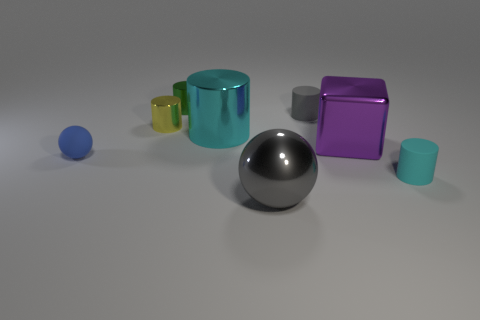There is a cylinder that is the same color as the large sphere; what material is it?
Offer a very short reply. Rubber. The matte cylinder that is the same color as the shiny sphere is what size?
Offer a very short reply. Small. Is the number of green metallic objects that are in front of the big gray shiny thing less than the number of purple blocks to the left of the yellow metallic object?
Make the answer very short. No. Is there any other thing that is the same material as the big cube?
Keep it short and to the point. Yes. There is a purple object that is made of the same material as the big sphere; what shape is it?
Make the answer very short. Cube. Are there any other things that have the same color as the small ball?
Provide a short and direct response. No. There is a sphere that is left of the ball that is in front of the rubber sphere; what is its color?
Offer a terse response. Blue. There is a gray thing that is to the right of the ball that is on the right side of the large cyan cylinder on the left side of the big gray metal object; what is it made of?
Provide a succinct answer. Rubber. How many purple metallic objects are the same size as the block?
Keep it short and to the point. 0. What is the material of the small thing that is right of the large gray object and to the left of the tiny cyan rubber thing?
Your answer should be very brief. Rubber. 